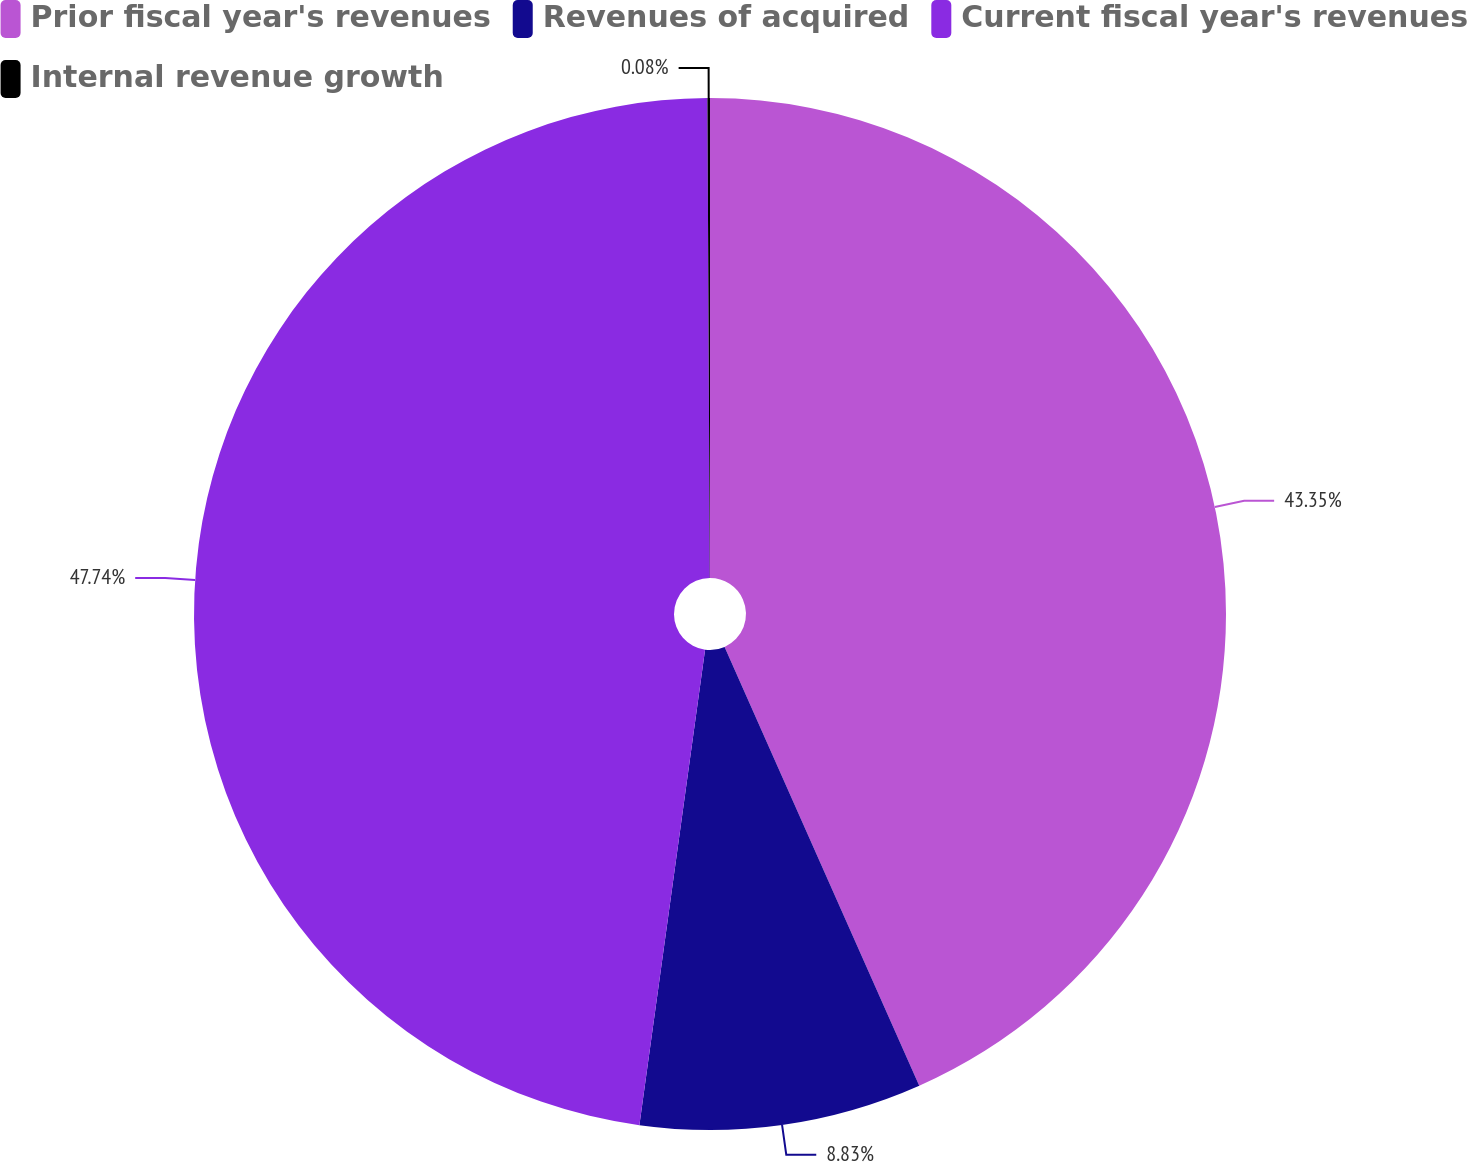Convert chart. <chart><loc_0><loc_0><loc_500><loc_500><pie_chart><fcel>Prior fiscal year's revenues<fcel>Revenues of acquired<fcel>Current fiscal year's revenues<fcel>Internal revenue growth<nl><fcel>43.35%<fcel>8.83%<fcel>47.73%<fcel>0.08%<nl></chart> 